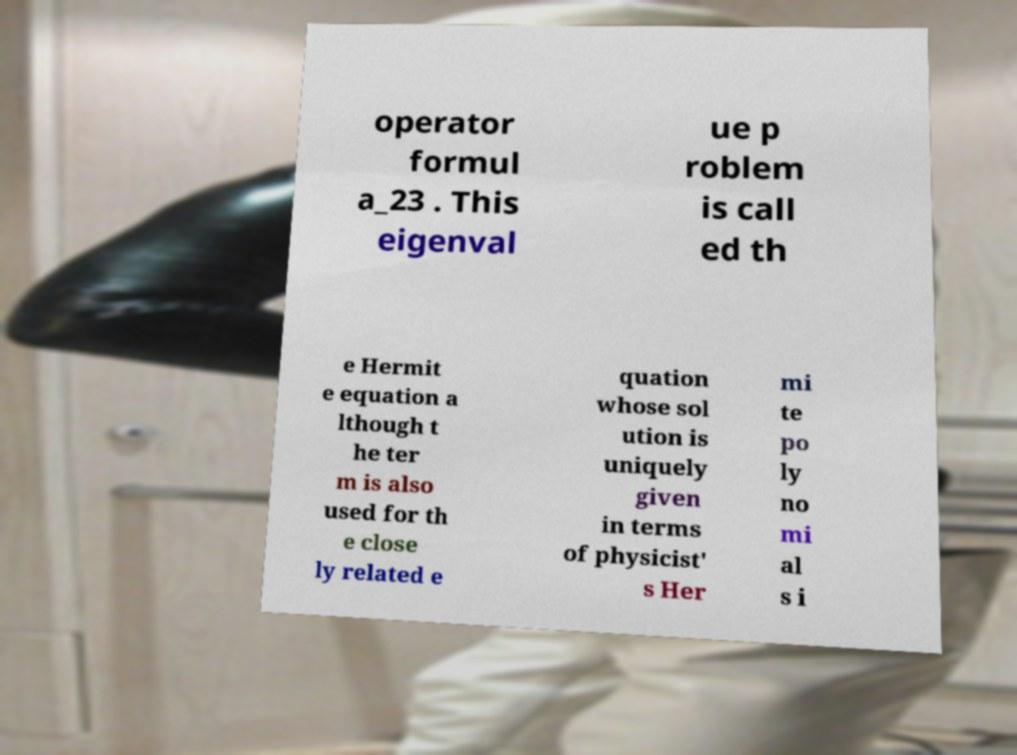Please identify and transcribe the text found in this image. operator formul a_23 . This eigenval ue p roblem is call ed th e Hermit e equation a lthough t he ter m is also used for th e close ly related e quation whose sol ution is uniquely given in terms of physicist' s Her mi te po ly no mi al s i 